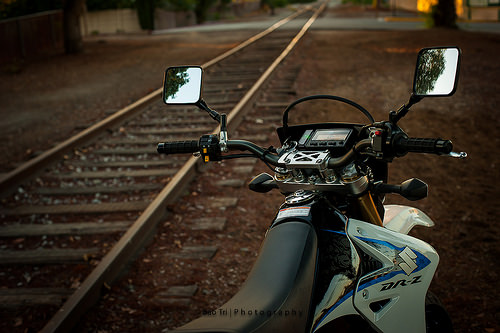<image>
Is there a bike next to the train tracks? Yes. The bike is positioned adjacent to the train tracks, located nearby in the same general area. Is the mirror behind the seat? No. The mirror is not behind the seat. From this viewpoint, the mirror appears to be positioned elsewhere in the scene. 